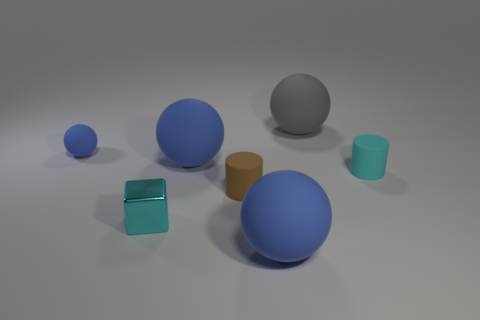How many gray things have the same shape as the cyan matte object?
Ensure brevity in your answer.  0. What material is the blue object to the left of the big blue ball that is behind the rubber object that is right of the big gray rubber thing?
Make the answer very short. Rubber. Are there any matte things on the right side of the shiny thing?
Your answer should be compact. Yes. What is the shape of the shiny thing that is the same size as the cyan cylinder?
Offer a very short reply. Cube. Is the brown thing made of the same material as the small blue ball?
Your response must be concise. Yes. What number of metal objects are either tiny blue balls or small cyan cylinders?
Provide a succinct answer. 0. There is a matte thing that is the same color as the tiny cube; what is its shape?
Offer a terse response. Cylinder. There is a small matte cylinder that is behind the tiny brown cylinder; is it the same color as the tiny metallic thing?
Keep it short and to the point. Yes. There is a cyan object left of the brown matte cylinder behind the cyan metallic cube; what shape is it?
Provide a short and direct response. Cube. What number of things are either big rubber balls that are in front of the tiny metallic block or blue rubber balls in front of the cyan matte object?
Offer a very short reply. 1. 